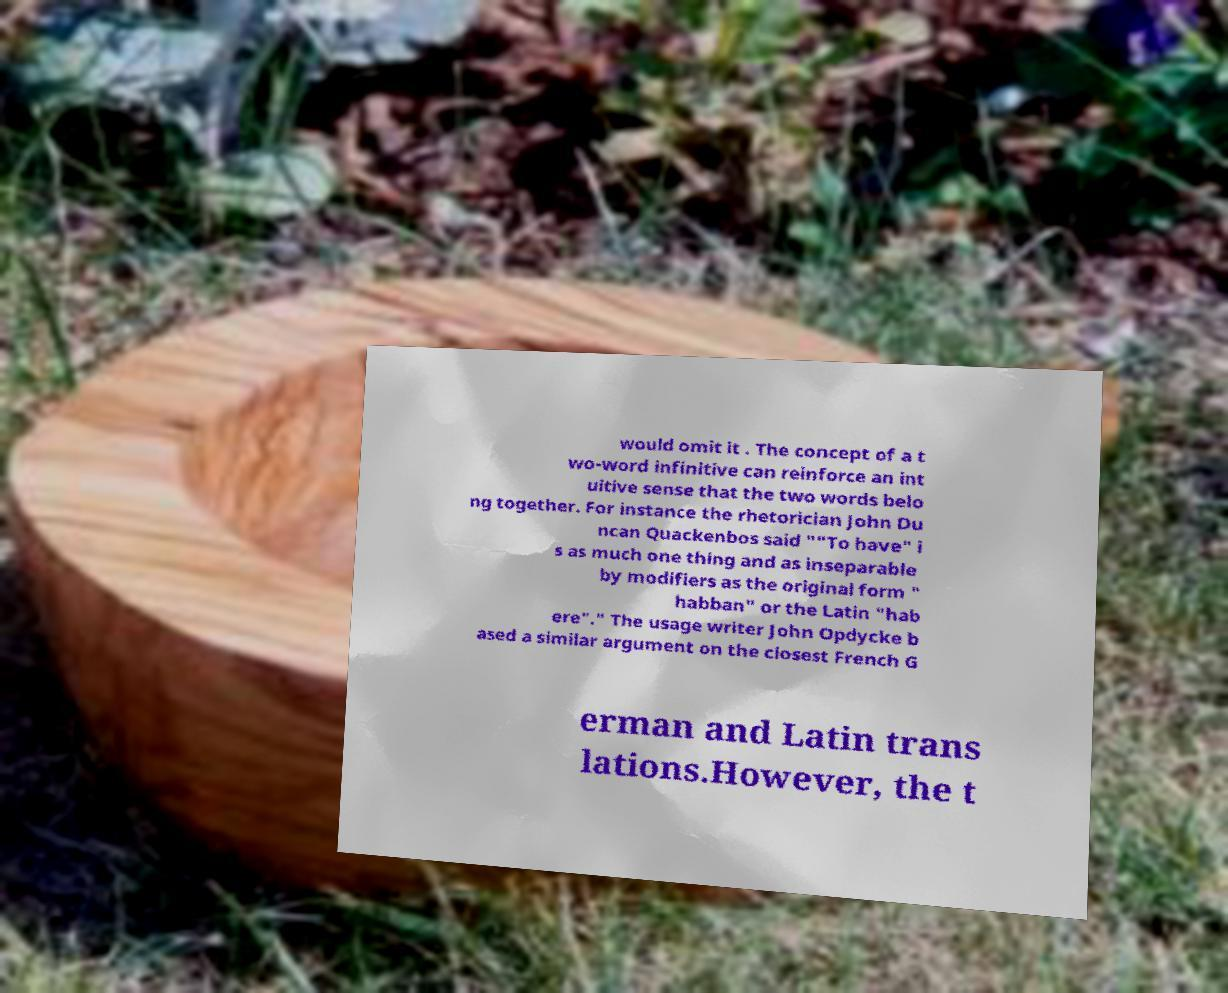Can you accurately transcribe the text from the provided image for me? would omit it . The concept of a t wo-word infinitive can reinforce an int uitive sense that the two words belo ng together. For instance the rhetorician John Du ncan Quackenbos said ""To have" i s as much one thing and as inseparable by modifiers as the original form " habban" or the Latin "hab ere"." The usage writer John Opdycke b ased a similar argument on the closest French G erman and Latin trans lations.However, the t 